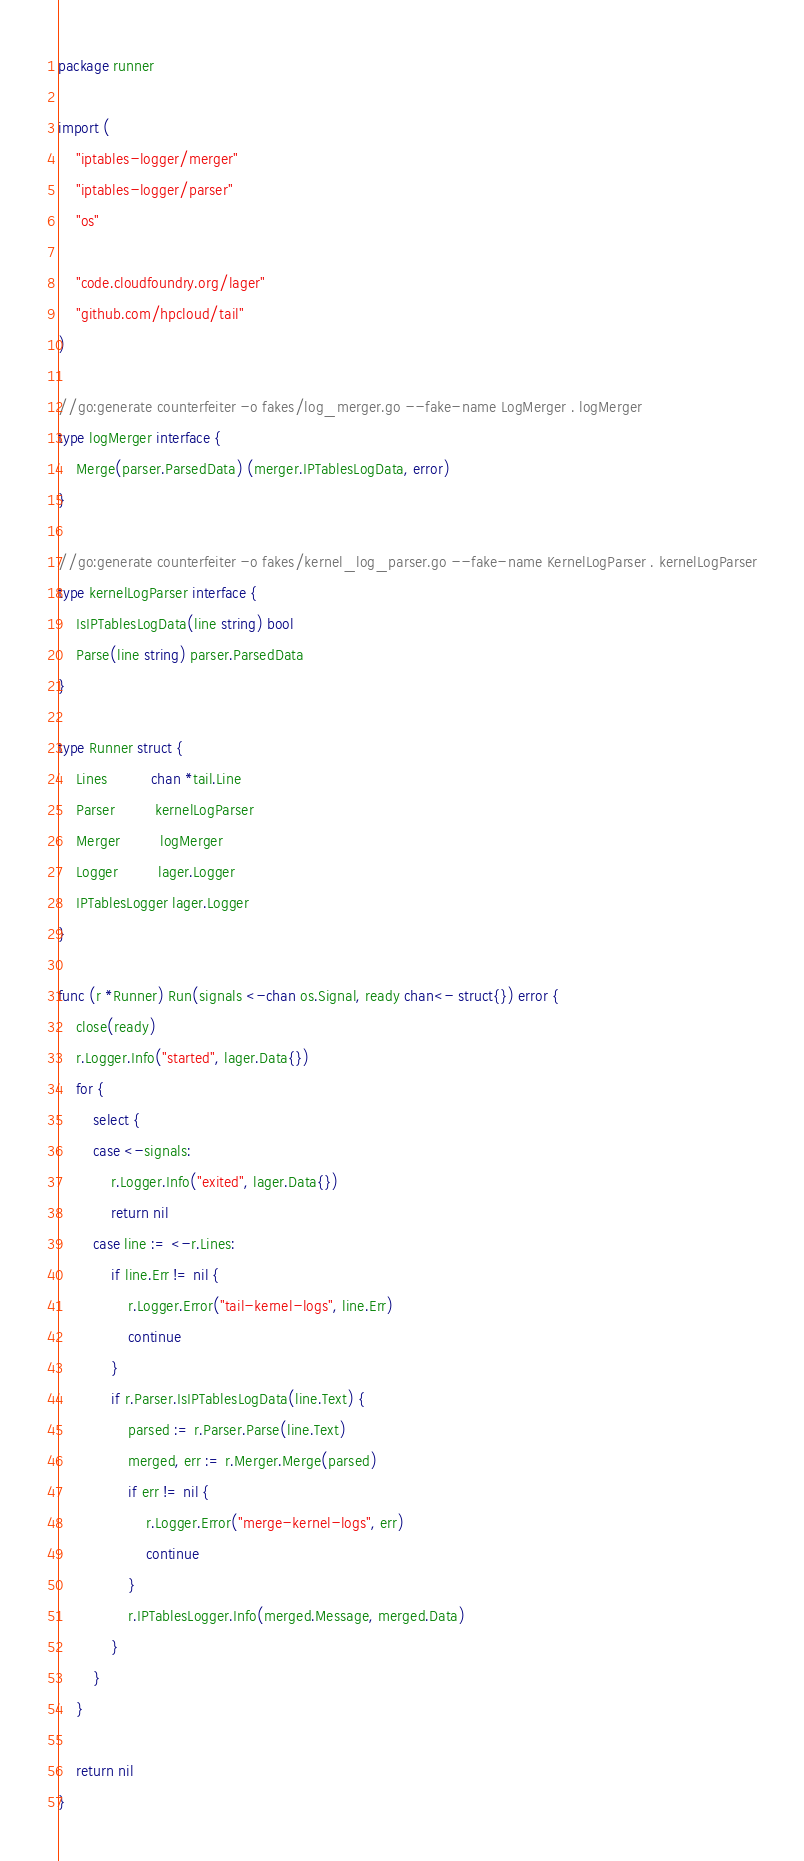Convert code to text. <code><loc_0><loc_0><loc_500><loc_500><_Go_>package runner

import (
	"iptables-logger/merger"
	"iptables-logger/parser"
	"os"

	"code.cloudfoundry.org/lager"
	"github.com/hpcloud/tail"
)

//go:generate counterfeiter -o fakes/log_merger.go --fake-name LogMerger . logMerger
type logMerger interface {
	Merge(parser.ParsedData) (merger.IPTablesLogData, error)
}

//go:generate counterfeiter -o fakes/kernel_log_parser.go --fake-name KernelLogParser . kernelLogParser
type kernelLogParser interface {
	IsIPTablesLogData(line string) bool
	Parse(line string) parser.ParsedData
}

type Runner struct {
	Lines          chan *tail.Line
	Parser         kernelLogParser
	Merger         logMerger
	Logger         lager.Logger
	IPTablesLogger lager.Logger
}

func (r *Runner) Run(signals <-chan os.Signal, ready chan<- struct{}) error {
	close(ready)
	r.Logger.Info("started", lager.Data{})
	for {
		select {
		case <-signals:
			r.Logger.Info("exited", lager.Data{})
			return nil
		case line := <-r.Lines:
			if line.Err != nil {
				r.Logger.Error("tail-kernel-logs", line.Err)
				continue
			}
			if r.Parser.IsIPTablesLogData(line.Text) {
				parsed := r.Parser.Parse(line.Text)
				merged, err := r.Merger.Merge(parsed)
				if err != nil {
					r.Logger.Error("merge-kernel-logs", err)
					continue
				}
				r.IPTablesLogger.Info(merged.Message, merged.Data)
			}
		}
	}

	return nil
}
</code> 